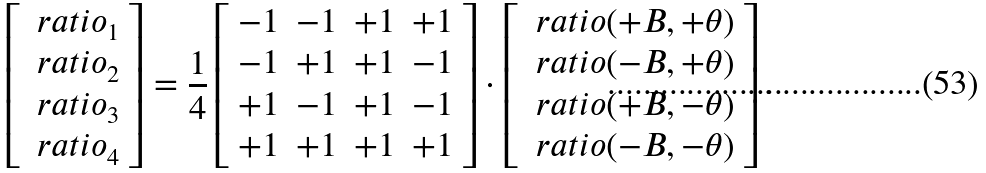<formula> <loc_0><loc_0><loc_500><loc_500>\left [ \begin{array} { c } \ r a t i o _ { 1 } \\ \ r a t i o _ { 2 } \\ \ r a t i o _ { 3 } \\ \ r a t i o _ { 4 } \end{array} \right ] = \frac { 1 } { 4 } \left [ \begin{array} { r r r r } - 1 & - 1 & + 1 & + 1 \\ - 1 & + 1 & + 1 & - 1 \\ + 1 & - 1 & + 1 & - 1 \\ + 1 & + 1 & + 1 & + 1 \end{array} \right ] \cdot \left [ \begin{array} { c } \ r a t i o ( + B , + \theta ) \\ \ r a t i o ( - B , + \theta ) \\ \ r a t i o ( + B , - \theta ) \\ \ r a t i o ( - B , - \theta ) \end{array} \right ] .</formula> 